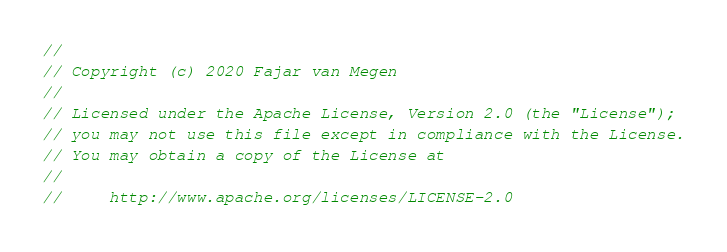Convert code to text. <code><loc_0><loc_0><loc_500><loc_500><_Dart_>//
// Copyright (c) 2020 Fajar van Megen
//
// Licensed under the Apache License, Version 2.0 (the "License");
// you may not use this file except in compliance with the License.
// You may obtain a copy of the License at
//
//     http://www.apache.org/licenses/LICENSE-2.0</code> 